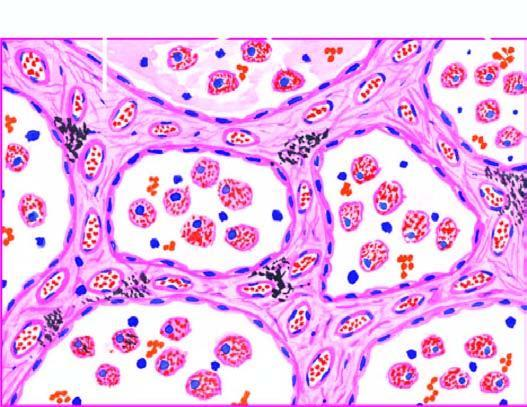what are widened and thickened due to congestion, oedema and mild fibrosis?
Answer the question using a single word or phrase. The alveolar sept 